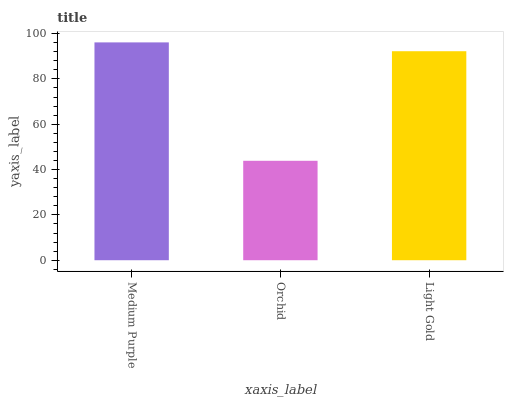Is Orchid the minimum?
Answer yes or no. Yes. Is Medium Purple the maximum?
Answer yes or no. Yes. Is Light Gold the minimum?
Answer yes or no. No. Is Light Gold the maximum?
Answer yes or no. No. Is Light Gold greater than Orchid?
Answer yes or no. Yes. Is Orchid less than Light Gold?
Answer yes or no. Yes. Is Orchid greater than Light Gold?
Answer yes or no. No. Is Light Gold less than Orchid?
Answer yes or no. No. Is Light Gold the high median?
Answer yes or no. Yes. Is Light Gold the low median?
Answer yes or no. Yes. Is Orchid the high median?
Answer yes or no. No. Is Orchid the low median?
Answer yes or no. No. 